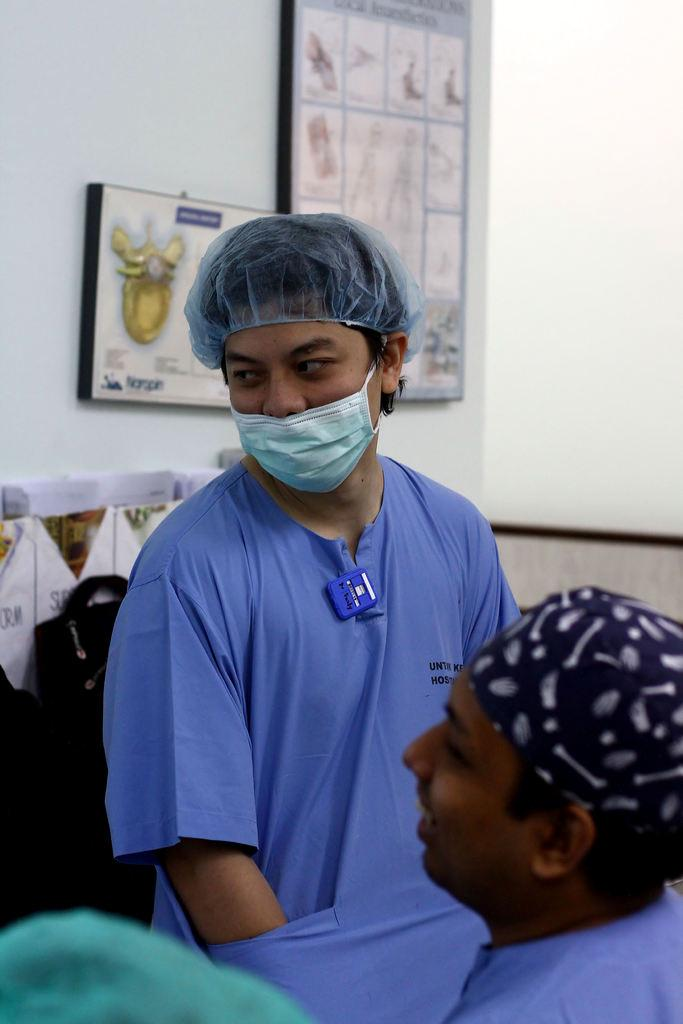What is the main subject of the image? There are persons in the center of the image. What can be seen in the background of the image? There are pictures of organs and a wall visible in the background. What type of pickle is being served at the dinner table in the image? There is no dinner table or pickle present in the image. What type of wire is connected to the organs in the image? There are no wires connected to the organs in the image; they are simply pictures in the background. 